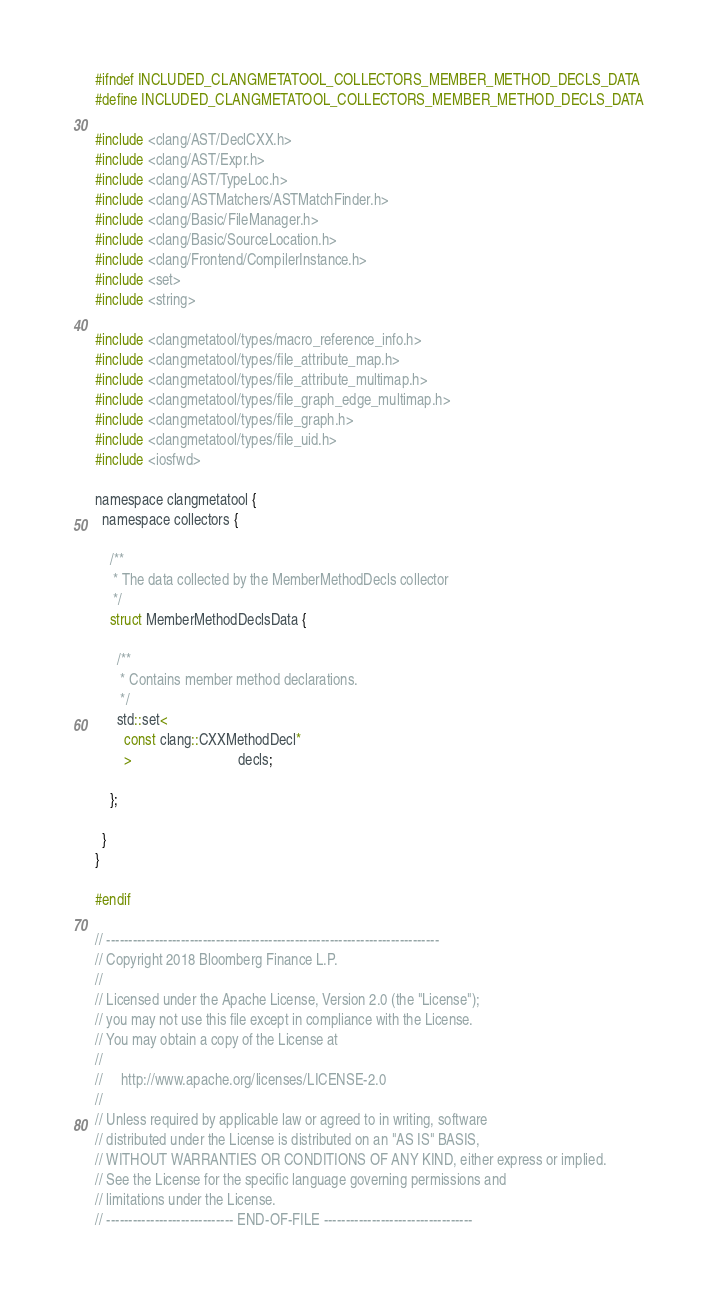Convert code to text. <code><loc_0><loc_0><loc_500><loc_500><_C_>#ifndef INCLUDED_CLANGMETATOOL_COLLECTORS_MEMBER_METHOD_DECLS_DATA
#define INCLUDED_CLANGMETATOOL_COLLECTORS_MEMBER_METHOD_DECLS_DATA

#include <clang/AST/DeclCXX.h>
#include <clang/AST/Expr.h>
#include <clang/AST/TypeLoc.h>
#include <clang/ASTMatchers/ASTMatchFinder.h>
#include <clang/Basic/FileManager.h>
#include <clang/Basic/SourceLocation.h>
#include <clang/Frontend/CompilerInstance.h>
#include <set>
#include <string>

#include <clangmetatool/types/macro_reference_info.h>
#include <clangmetatool/types/file_attribute_map.h>
#include <clangmetatool/types/file_attribute_multimap.h>
#include <clangmetatool/types/file_graph_edge_multimap.h>
#include <clangmetatool/types/file_graph.h>
#include <clangmetatool/types/file_uid.h>
#include <iosfwd>

namespace clangmetatool {
  namespace collectors {

    /**
     * The data collected by the MemberMethodDecls collector
     */
    struct MemberMethodDeclsData {

      /**
       * Contains member method declarations.
       */
      std::set<
        const clang::CXXMethodDecl*
        >                             decls;

    };

  }
}

#endif

// ----------------------------------------------------------------------------
// Copyright 2018 Bloomberg Finance L.P.
//
// Licensed under the Apache License, Version 2.0 (the "License");
// you may not use this file except in compliance with the License.
// You may obtain a copy of the License at
//
//     http://www.apache.org/licenses/LICENSE-2.0
//
// Unless required by applicable law or agreed to in writing, software
// distributed under the License is distributed on an "AS IS" BASIS,
// WITHOUT WARRANTIES OR CONDITIONS OF ANY KIND, either express or implied.
// See the License for the specific language governing permissions and
// limitations under the License.
// ----------------------------- END-OF-FILE ----------------------------------
</code> 